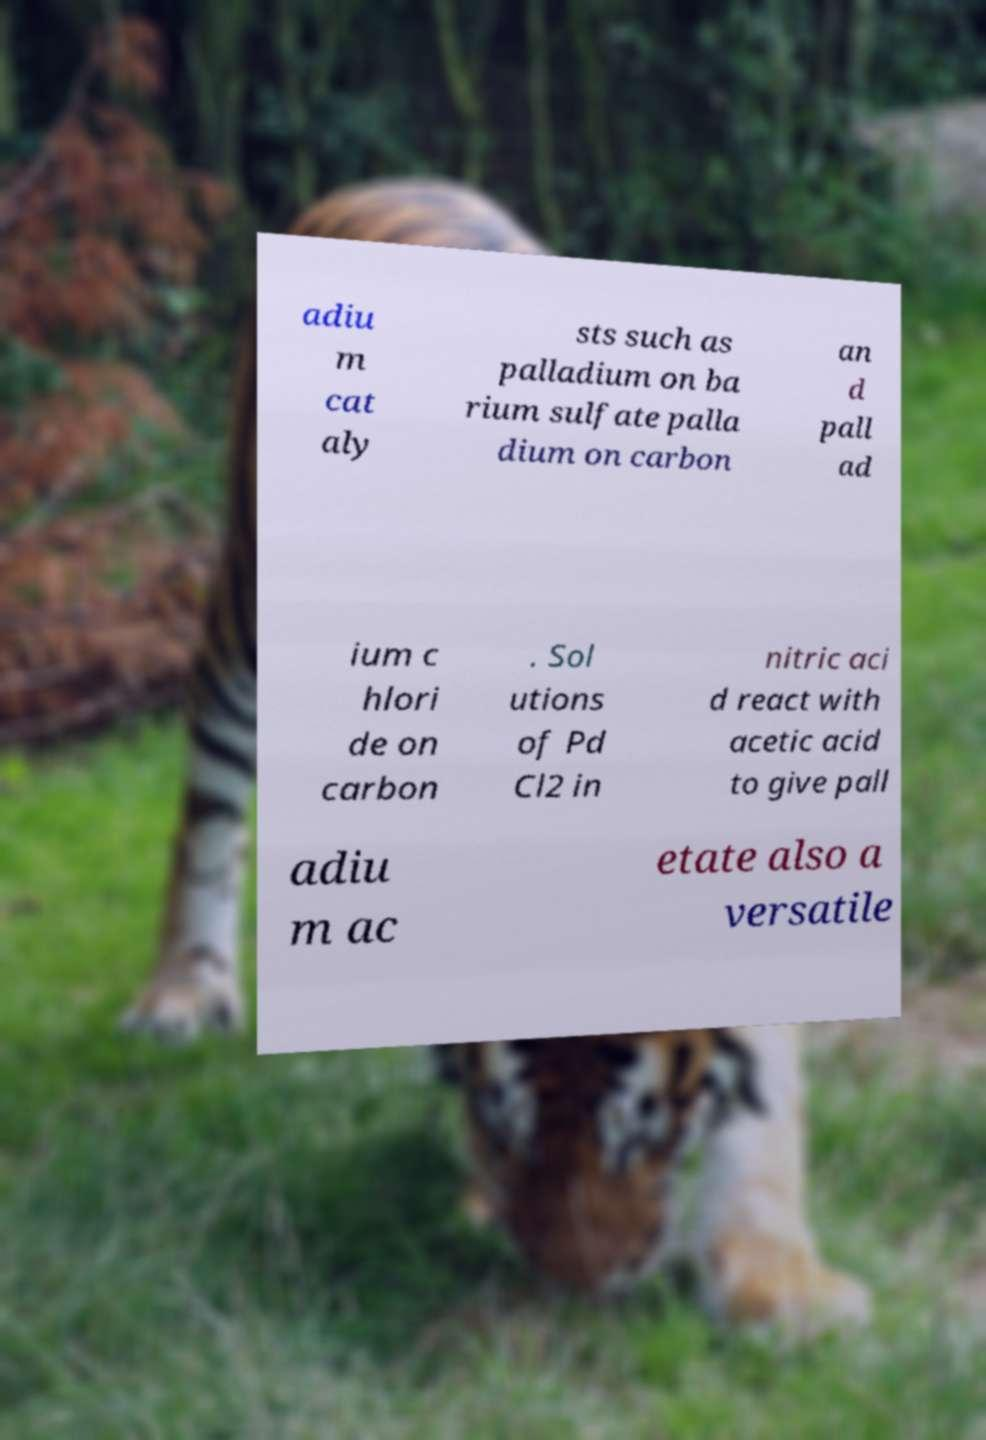Can you read and provide the text displayed in the image?This photo seems to have some interesting text. Can you extract and type it out for me? adiu m cat aly sts such as palladium on ba rium sulfate palla dium on carbon an d pall ad ium c hlori de on carbon . Sol utions of Pd Cl2 in nitric aci d react with acetic acid to give pall adiu m ac etate also a versatile 